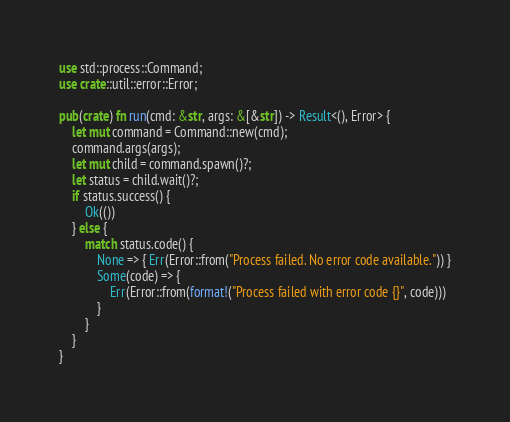<code> <loc_0><loc_0><loc_500><loc_500><_Rust_>use std::process::Command;
use crate::util::error::Error;

pub(crate) fn run(cmd: &str, args: &[&str]) -> Result<(), Error> {
    let mut command = Command::new(cmd);
    command.args(args);
    let mut child = command.spawn()?;
    let status = child.wait()?;
    if status.success() {
        Ok(())
    } else {
        match status.code() {
            None => { Err(Error::from("Process failed. No error code available.")) }
            Some(code) => {
                Err(Error::from(format!("Process failed with error code {}", code)))
            }
        }
    }
}</code> 